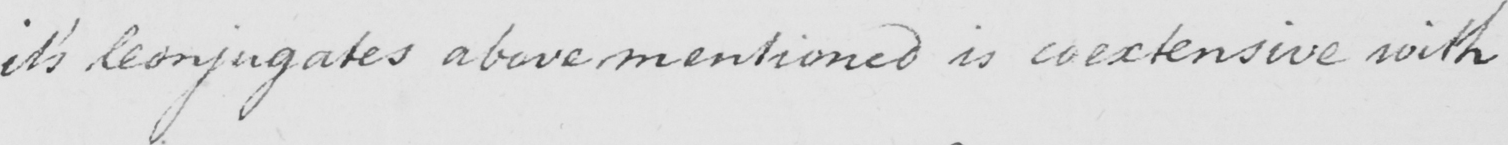What text is written in this handwritten line? it ' s Conjugates above mentioned is coextensive with 